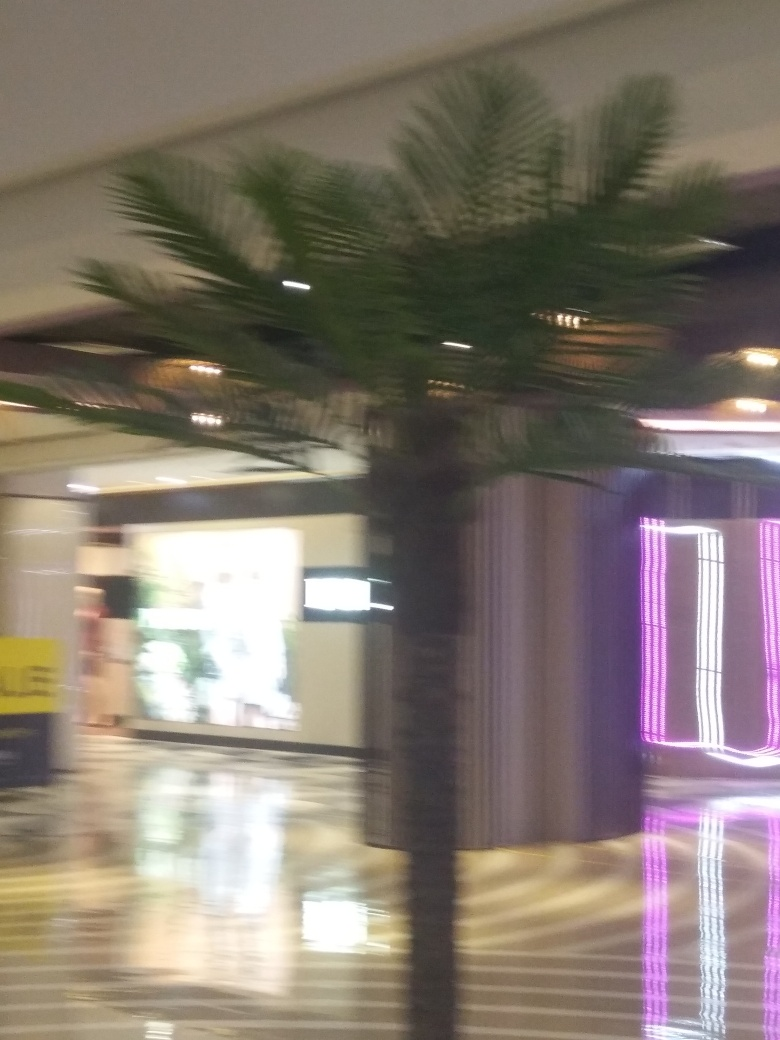Is the image of poor quality?
A. Yes
B. No
Answer with the option's letter from the given choices directly.
 A. 